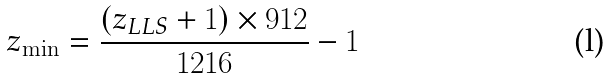<formula> <loc_0><loc_0><loc_500><loc_500>z _ { \min } = \frac { ( z _ { L L S } + 1 ) \times 9 1 2 } { 1 2 1 6 } - 1</formula> 